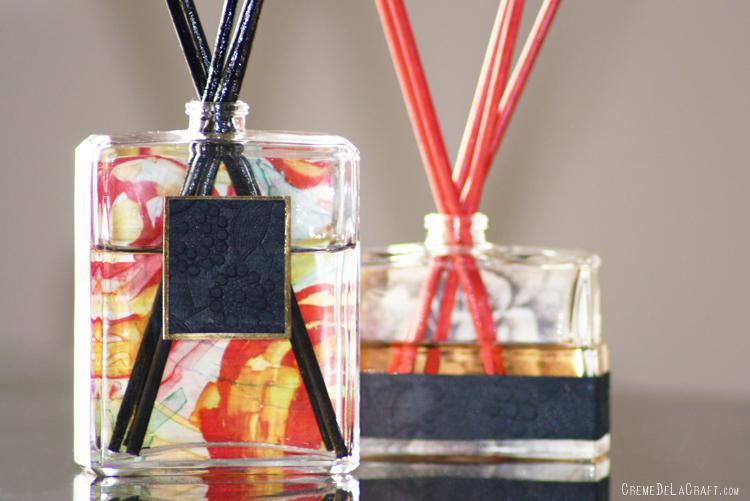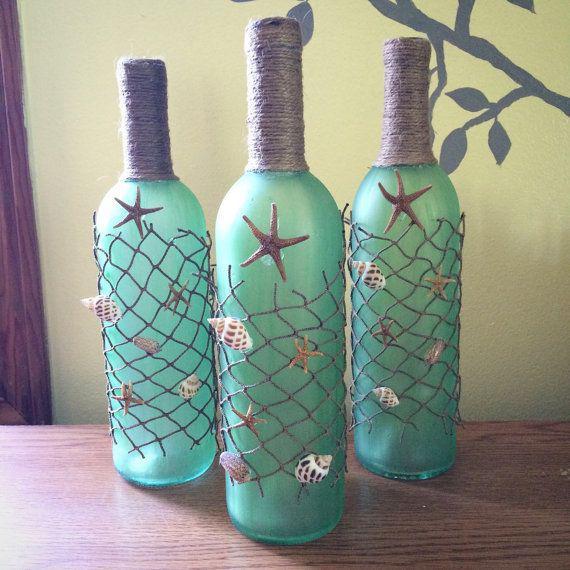The first image is the image on the left, the second image is the image on the right. Evaluate the accuracy of this statement regarding the images: "All bottles have wooden caps and at least one bottle has a braided strap attached.". Is it true? Answer yes or no. No. The first image is the image on the left, the second image is the image on the right. For the images shown, is this caption "At least 4 bottles are lined up in a straight row." true? Answer yes or no. No. 